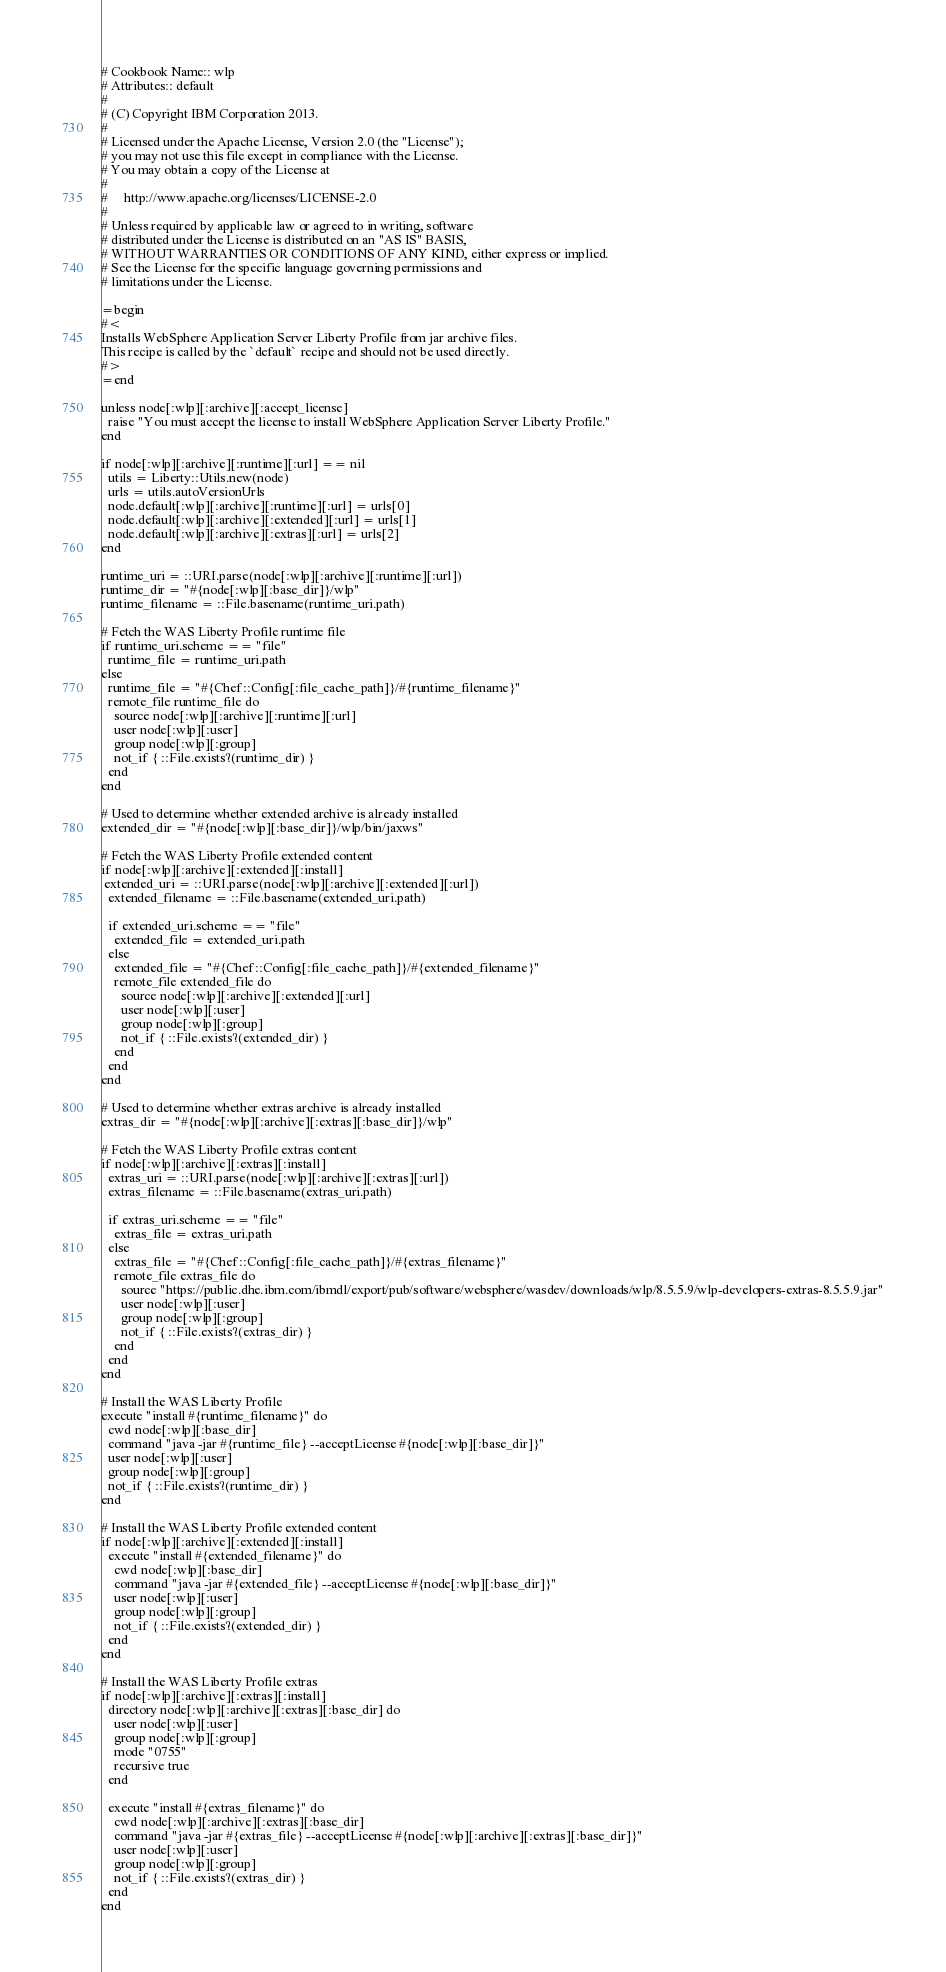<code> <loc_0><loc_0><loc_500><loc_500><_Ruby_># Cookbook Name:: wlp
# Attributes:: default
#
# (C) Copyright IBM Corporation 2013.
#
# Licensed under the Apache License, Version 2.0 (the "License");
# you may not use this file except in compliance with the License.
# You may obtain a copy of the License at
#
#     http://www.apache.org/licenses/LICENSE-2.0
#
# Unless required by applicable law or agreed to in writing, software
# distributed under the License is distributed on an "AS IS" BASIS,
# WITHOUT WARRANTIES OR CONDITIONS OF ANY KIND, either express or implied.
# See the License for the specific language governing permissions and
# limitations under the License.

=begin
#<
Installs WebSphere Application Server Liberty Profile from jar archive files. 
This recipe is called by the `default` recipe and should not be used directly.
#>
=end

unless node[:wlp][:archive][:accept_license]
  raise "You must accept the license to install WebSphere Application Server Liberty Profile."
end

if node[:wlp][:archive][:runtime][:url] == nil
  utils = Liberty::Utils.new(node)
  urls = utils.autoVersionUrls
  node.default[:wlp][:archive][:runtime][:url] = urls[0]
  node.default[:wlp][:archive][:extended][:url] = urls[1]
  node.default[:wlp][:archive][:extras][:url] = urls[2]
end

runtime_uri = ::URI.parse(node[:wlp][:archive][:runtime][:url])
runtime_dir = "#{node[:wlp][:base_dir]}/wlp"
runtime_filename = ::File.basename(runtime_uri.path)

# Fetch the WAS Liberty Profile runtime file
if runtime_uri.scheme == "file"
  runtime_file = runtime_uri.path
else
  runtime_file = "#{Chef::Config[:file_cache_path]}/#{runtime_filename}"
  remote_file runtime_file do
    source node[:wlp][:archive][:runtime][:url]
    user node[:wlp][:user]
    group node[:wlp][:group]
    not_if { ::File.exists?(runtime_dir) }
  end
end

# Used to determine whether extended archive is already installed
extended_dir = "#{node[:wlp][:base_dir]}/wlp/bin/jaxws"

# Fetch the WAS Liberty Profile extended content
if node[:wlp][:archive][:extended][:install]
 extended_uri = ::URI.parse(node[:wlp][:archive][:extended][:url])
  extended_filename = ::File.basename(extended_uri.path)

  if extended_uri.scheme == "file"
    extended_file = extended_uri.path
  else
    extended_file = "#{Chef::Config[:file_cache_path]}/#{extended_filename}"
    remote_file extended_file do
      source node[:wlp][:archive][:extended][:url]
      user node[:wlp][:user]
      group node[:wlp][:group]
      not_if { ::File.exists?(extended_dir) }
    end
  end
end

# Used to determine whether extras archive is already installed
extras_dir = "#{node[:wlp][:archive][:extras][:base_dir]}/wlp"

# Fetch the WAS Liberty Profile extras content
if node[:wlp][:archive][:extras][:install]
  extras_uri = ::URI.parse(node[:wlp][:archive][:extras][:url])
  extras_filename = ::File.basename(extras_uri.path)

  if extras_uri.scheme == "file"
    extras_file = extras_uri.path
  else
    extras_file = "#{Chef::Config[:file_cache_path]}/#{extras_filename}"
    remote_file extras_file do
      source "https://public.dhe.ibm.com/ibmdl/export/pub/software/websphere/wasdev/downloads/wlp/8.5.5.9/wlp-developers-extras-8.5.5.9.jar"
      user node[:wlp][:user]
      group node[:wlp][:group]
      not_if { ::File.exists?(extras_dir) }
    end
  end
end

# Install the WAS Liberty Profile
execute "install #{runtime_filename}" do
  cwd node[:wlp][:base_dir]
  command "java -jar #{runtime_file} --acceptLicense #{node[:wlp][:base_dir]}" 
  user node[:wlp][:user]
  group node[:wlp][:group]
  not_if { ::File.exists?(runtime_dir) }
end

# Install the WAS Liberty Profile extended content
if node[:wlp][:archive][:extended][:install]
  execute "install #{extended_filename}" do
    cwd node[:wlp][:base_dir]
    command "java -jar #{extended_file} --acceptLicense #{node[:wlp][:base_dir]}" 
    user node[:wlp][:user]
    group node[:wlp][:group]
    not_if { ::File.exists?(extended_dir) }
  end
end

# Install the WAS Liberty Profile extras
if node[:wlp][:archive][:extras][:install]
  directory node[:wlp][:archive][:extras][:base_dir] do
    user node[:wlp][:user]
    group node[:wlp][:group]
    mode "0755"
    recursive true
  end

  execute "install #{extras_filename}" do
    cwd node[:wlp][:archive][:extras][:base_dir]
    command "java -jar #{extras_file} --acceptLicense #{node[:wlp][:archive][:extras][:base_dir]}" 
    user node[:wlp][:user]
    group node[:wlp][:group]
    not_if { ::File.exists?(extras_dir) }
  end
end
</code> 